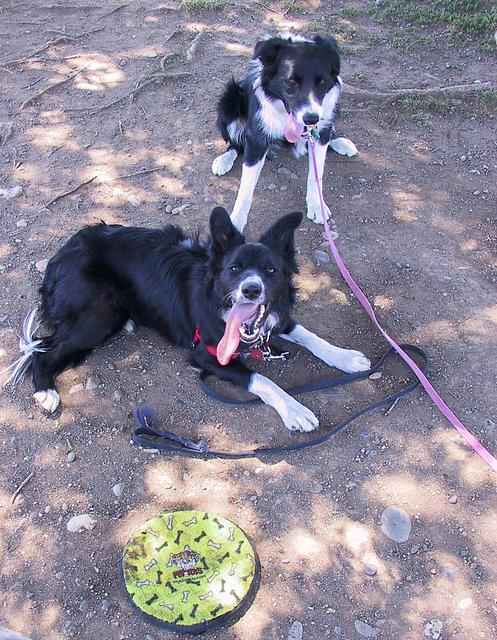What color is the lead to the dog standing to the rear side of the black dog? Please explain your reasoning. pink. The dog on the lead is wearing a pink leash. 